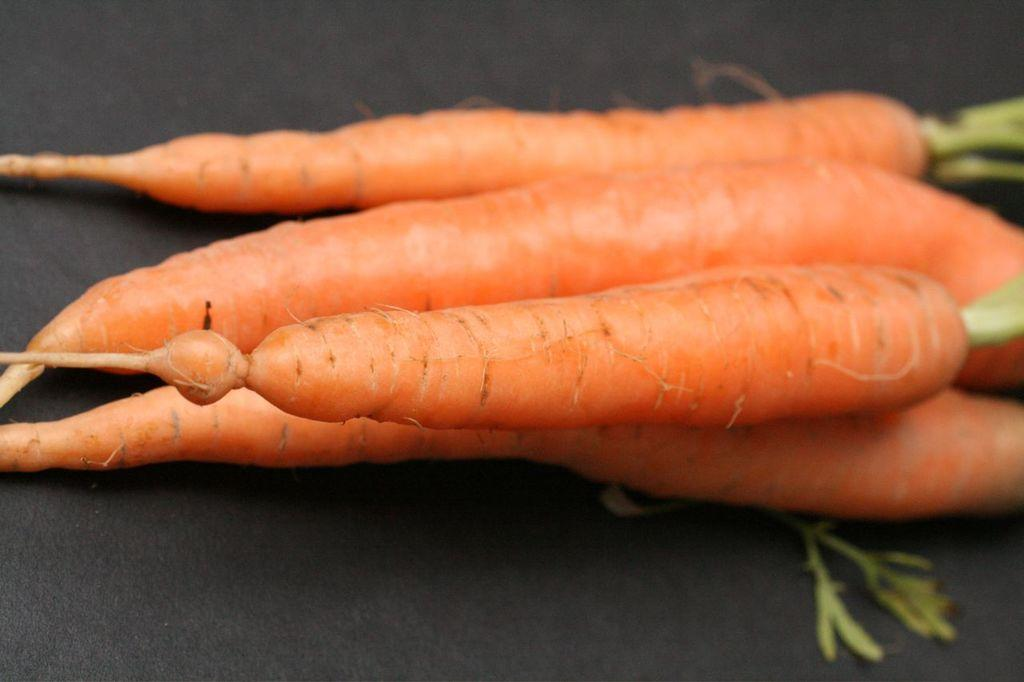What type of vegetable is present in the image? There are carrots in the image. What is the color of the carrots? The carrots are in orange color. Can you see a boy playing near a stream in the image? There is no boy or stream present in the image; it only features carrots. What is the size of the bit in the image? There is no bit present in the image. 